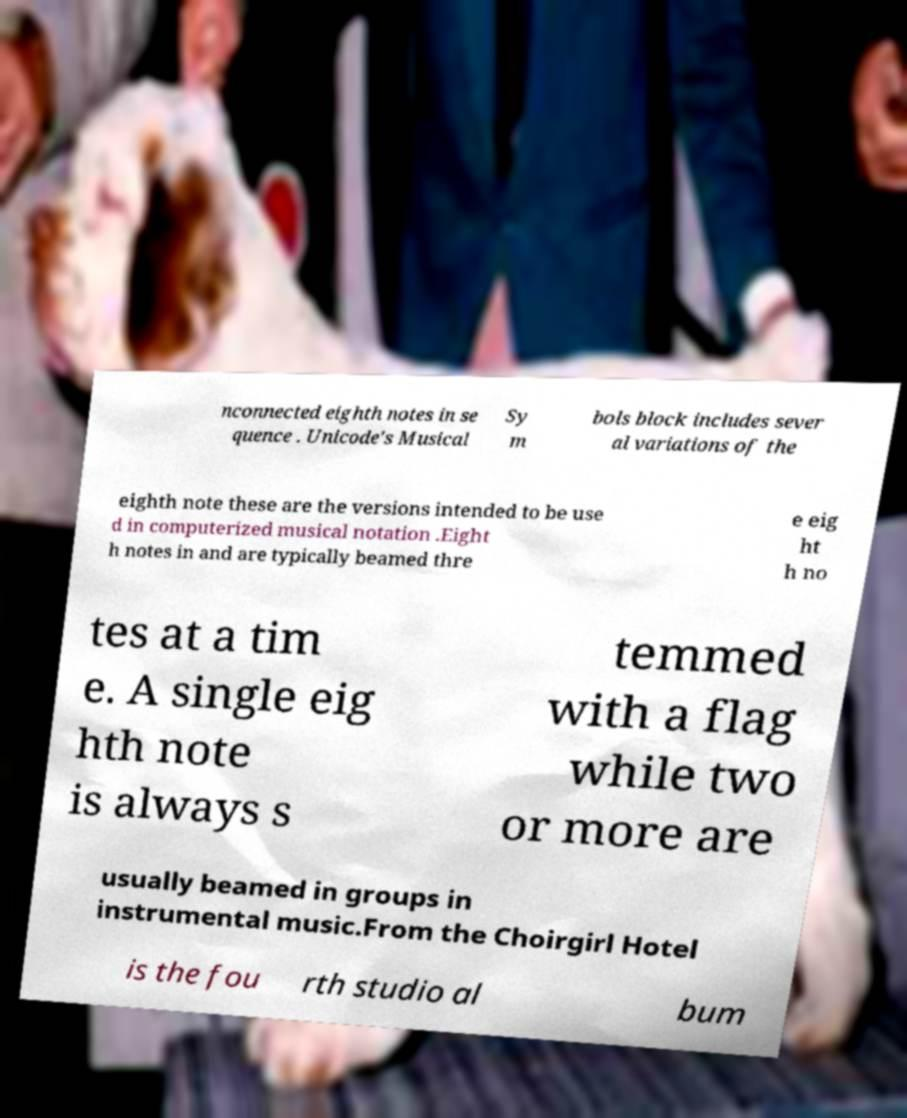Could you assist in decoding the text presented in this image and type it out clearly? nconnected eighth notes in se quence . Unicode's Musical Sy m bols block includes sever al variations of the eighth note these are the versions intended to be use d in computerized musical notation .Eight h notes in and are typically beamed thre e eig ht h no tes at a tim e. A single eig hth note is always s temmed with a flag while two or more are usually beamed in groups in instrumental music.From the Choirgirl Hotel is the fou rth studio al bum 